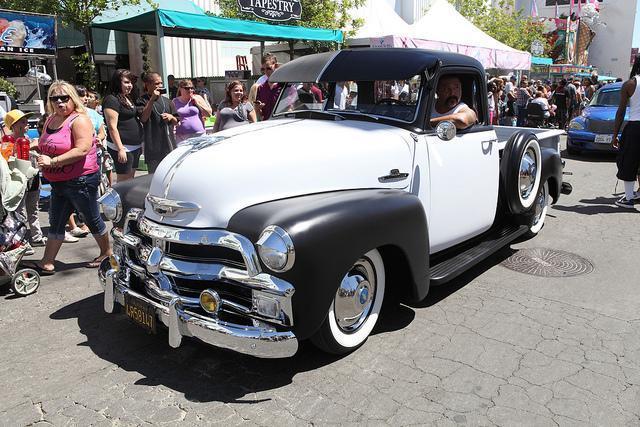How many tires does this vehicle have?
Give a very brief answer. 5. How many people are there?
Give a very brief answer. 6. 